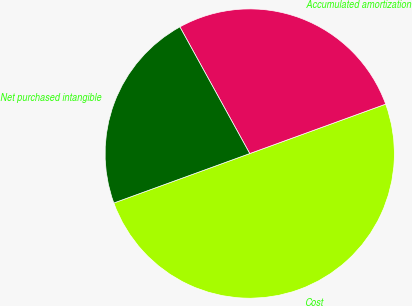<chart> <loc_0><loc_0><loc_500><loc_500><pie_chart><fcel>Cost<fcel>Accumulated amortization<fcel>Net purchased intangible<nl><fcel>50.0%<fcel>27.47%<fcel>22.53%<nl></chart> 